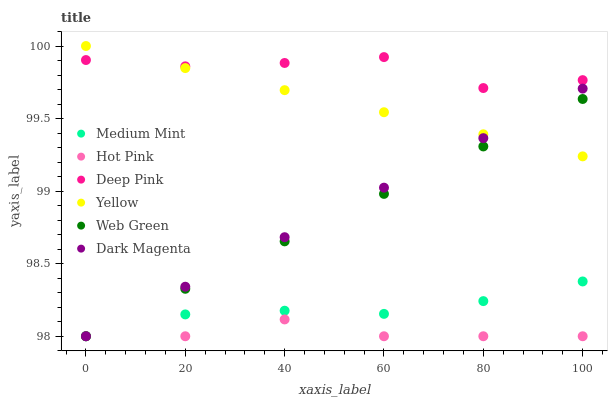Does Hot Pink have the minimum area under the curve?
Answer yes or no. Yes. Does Deep Pink have the maximum area under the curve?
Answer yes or no. Yes. Does Dark Magenta have the minimum area under the curve?
Answer yes or no. No. Does Dark Magenta have the maximum area under the curve?
Answer yes or no. No. Is Web Green the smoothest?
Answer yes or no. Yes. Is Deep Pink the roughest?
Answer yes or no. Yes. Is Dark Magenta the smoothest?
Answer yes or no. No. Is Dark Magenta the roughest?
Answer yes or no. No. Does Medium Mint have the lowest value?
Answer yes or no. Yes. Does Deep Pink have the lowest value?
Answer yes or no. No. Does Yellow have the highest value?
Answer yes or no. Yes. Does Deep Pink have the highest value?
Answer yes or no. No. Is Hot Pink less than Yellow?
Answer yes or no. Yes. Is Deep Pink greater than Dark Magenta?
Answer yes or no. Yes. Does Medium Mint intersect Web Green?
Answer yes or no. Yes. Is Medium Mint less than Web Green?
Answer yes or no. No. Is Medium Mint greater than Web Green?
Answer yes or no. No. Does Hot Pink intersect Yellow?
Answer yes or no. No. 